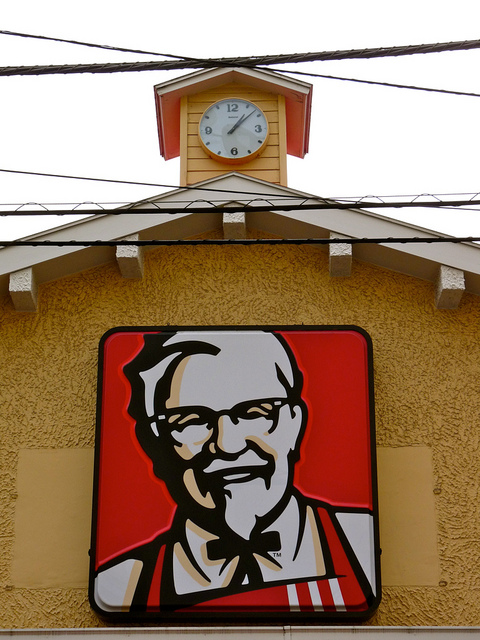Please transcribe the text information in this image. TM 6 3 9 12 